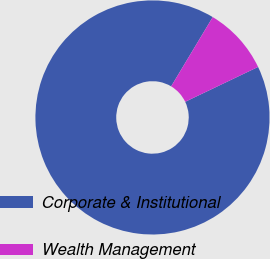<chart> <loc_0><loc_0><loc_500><loc_500><pie_chart><fcel>Corporate & Institutional<fcel>Wealth Management<nl><fcel>90.71%<fcel>9.29%<nl></chart> 